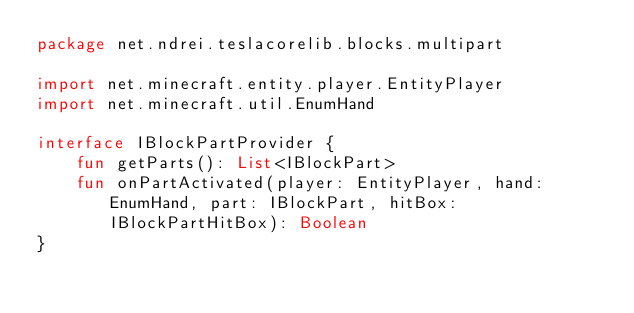Convert code to text. <code><loc_0><loc_0><loc_500><loc_500><_Kotlin_>package net.ndrei.teslacorelib.blocks.multipart

import net.minecraft.entity.player.EntityPlayer
import net.minecraft.util.EnumHand

interface IBlockPartProvider {
    fun getParts(): List<IBlockPart>
    fun onPartActivated(player: EntityPlayer, hand: EnumHand, part: IBlockPart, hitBox: IBlockPartHitBox): Boolean
}
</code> 